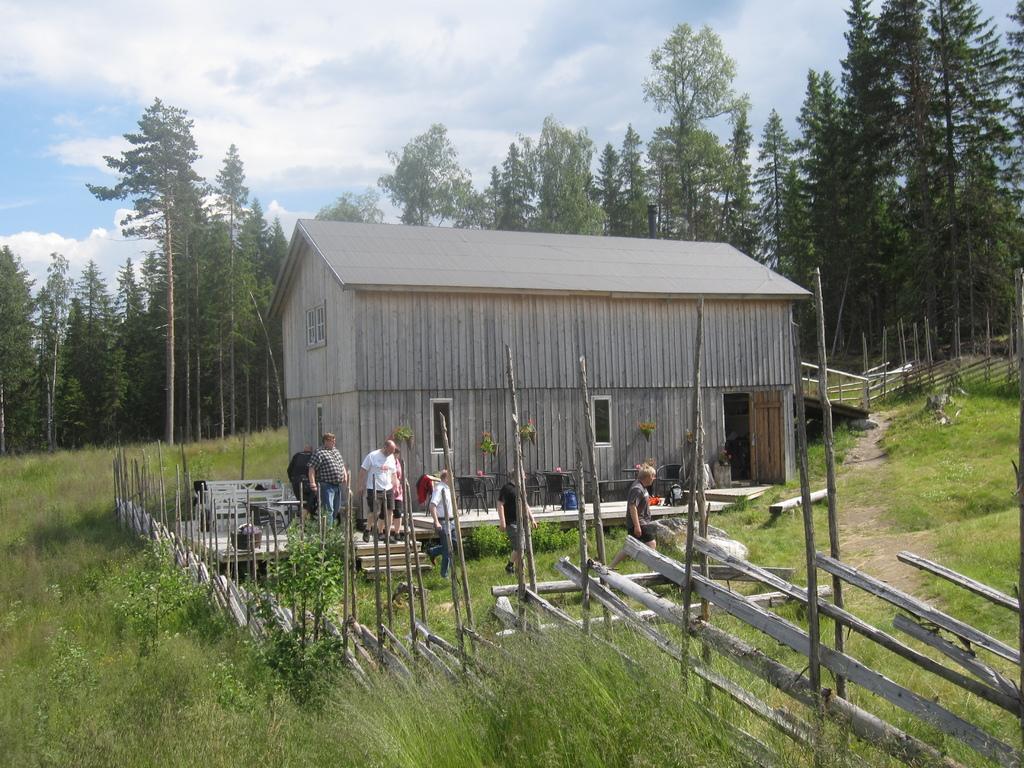In one or two sentences, can you explain what this image depicts? In this image we can see a building with windows and a door. Near to that there are chairs. Also there are steps. And there are few people. There is a fencing with wooden sticks. On the ground there are plants. In the background there are trees. Also there is sky with clouds. 